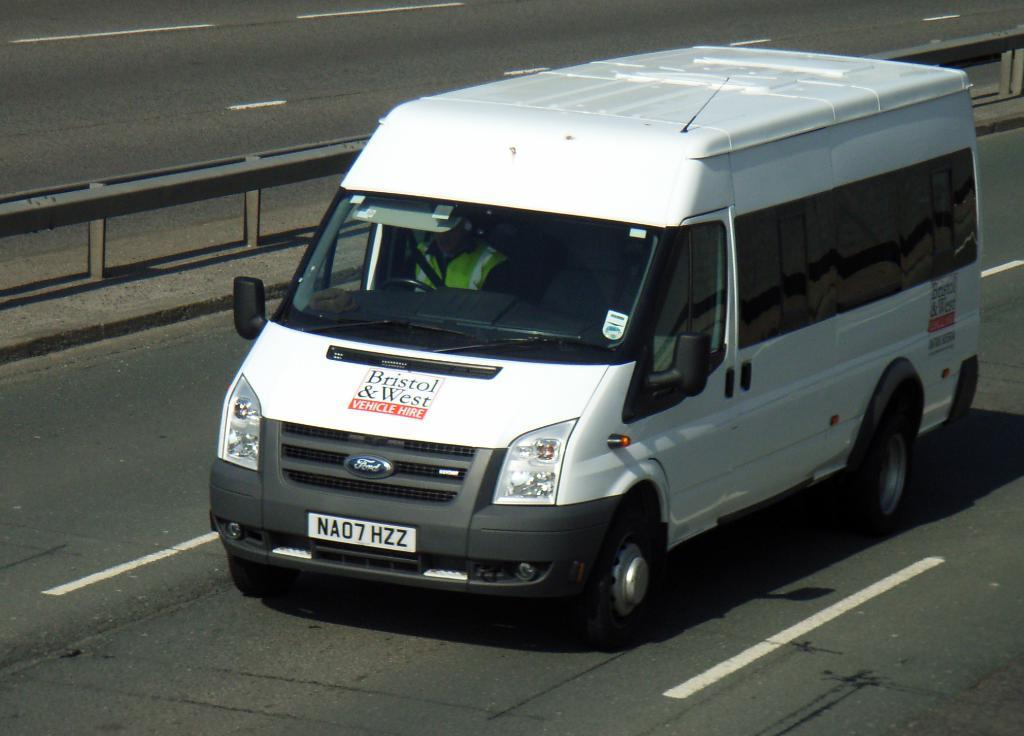<image>
Relay a brief, clear account of the picture shown. the letters NAO that are on a car 